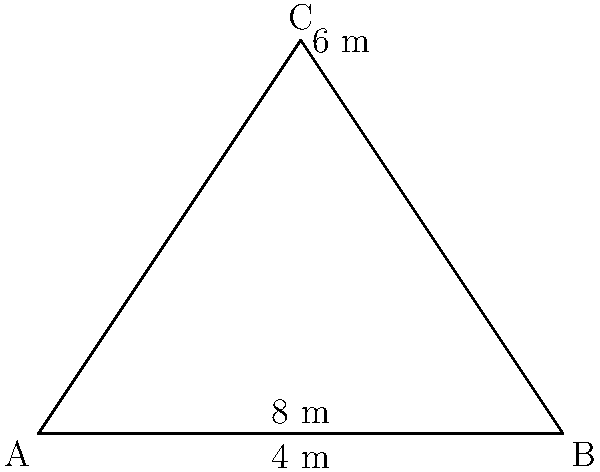For the upcoming fan meet-and-greet, you want to create a triangular banner to showcase your admiration. The banner will have a base of 8 meters and a height of 6 meters. What is the length of the two equal sides of this isosceles triangle banner to the nearest tenth of a meter? Let's approach this step-by-step:

1) We have an isosceles triangle with base 8 m and height 6 m.

2) The height bisects the base, creating two right triangles. Let's focus on one of these right triangles.

3) In this right triangle:
   - The base is half of 8 m, so 4 m
   - The height is 6 m
   - The hypotenuse is the side we're looking for

4) We can use the Pythagorean theorem to find the length of the side:

   $$a^2 + b^2 = c^2$$

   Where $a$ is the base half (4 m), $b$ is the height (6 m), and $c$ is the side we're looking for.

5) Plugging in the values:

   $$4^2 + 6^2 = c^2$$
   $$16 + 36 = c^2$$
   $$52 = c^2$$

6) Taking the square root of both sides:

   $$\sqrt{52} = c$$
   $$7.211 \approx c$$

7) Rounding to the nearest tenth:

   $$c \approx 7.2$$

Therefore, each of the two equal sides of the isosceles triangle banner is approximately 7.2 meters long.
Answer: 7.2 m 